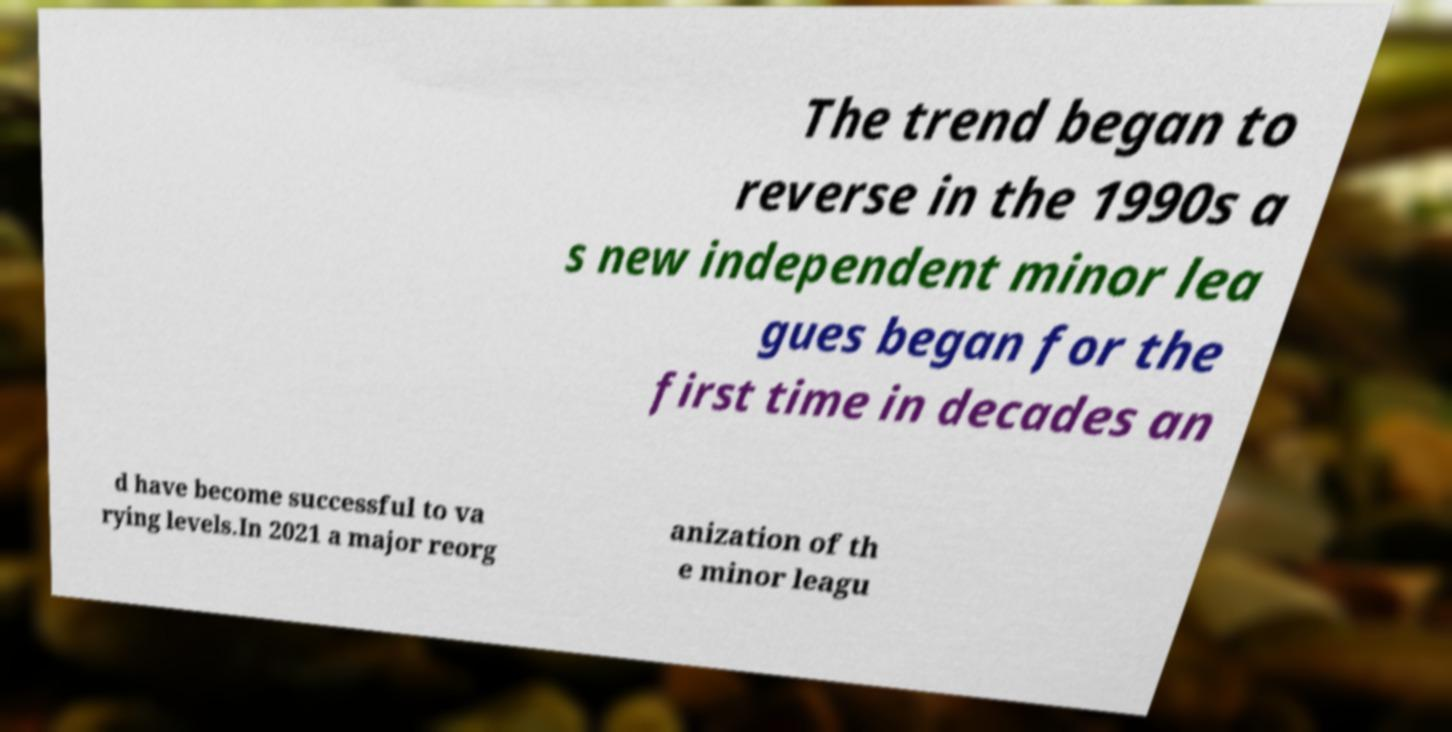There's text embedded in this image that I need extracted. Can you transcribe it verbatim? The trend began to reverse in the 1990s a s new independent minor lea gues began for the first time in decades an d have become successful to va rying levels.In 2021 a major reorg anization of th e minor leagu 